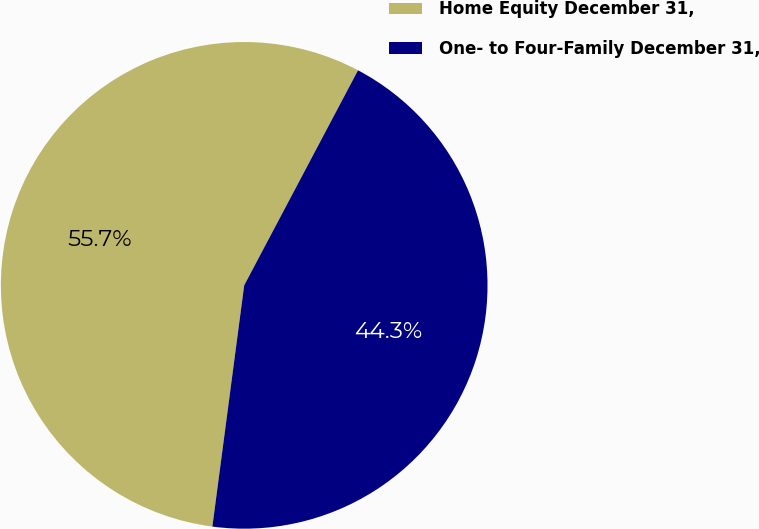Convert chart. <chart><loc_0><loc_0><loc_500><loc_500><pie_chart><fcel>Home Equity December 31,<fcel>One- to Four-Family December 31,<nl><fcel>55.66%<fcel>44.34%<nl></chart> 